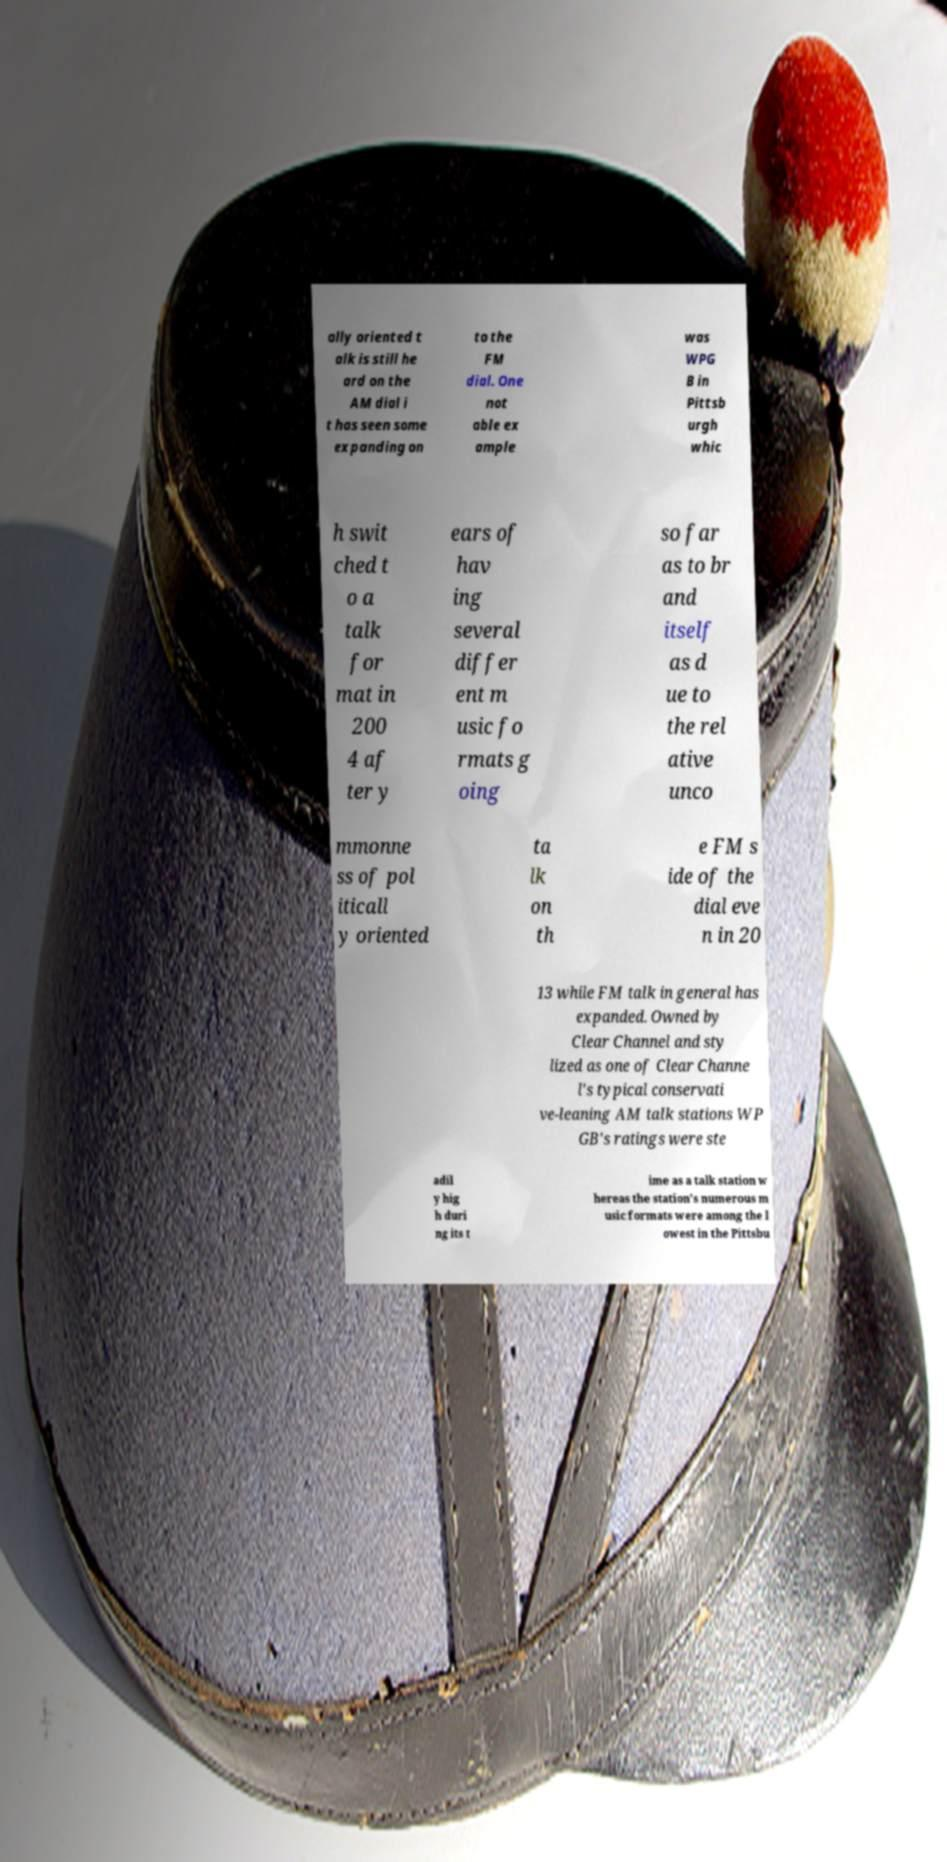Please identify and transcribe the text found in this image. ally oriented t alk is still he ard on the AM dial i t has seen some expanding on to the FM dial. One not able ex ample was WPG B in Pittsb urgh whic h swit ched t o a talk for mat in 200 4 af ter y ears of hav ing several differ ent m usic fo rmats g oing so far as to br and itself as d ue to the rel ative unco mmonne ss of pol iticall y oriented ta lk on th e FM s ide of the dial eve n in 20 13 while FM talk in general has expanded. Owned by Clear Channel and sty lized as one of Clear Channe l's typical conservati ve-leaning AM talk stations WP GB's ratings were ste adil y hig h duri ng its t ime as a talk station w hereas the station's numerous m usic formats were among the l owest in the Pittsbu 